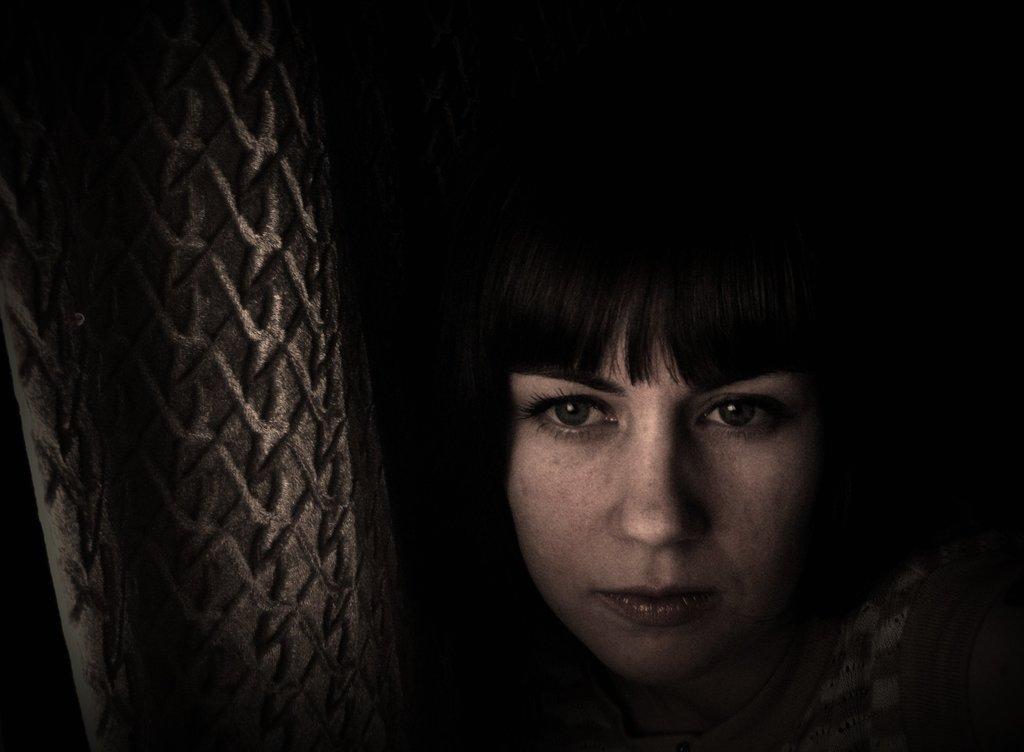Can you describe this image briefly? In this image, I can see the face of the woman. This looks like an object. The background looks dark. 